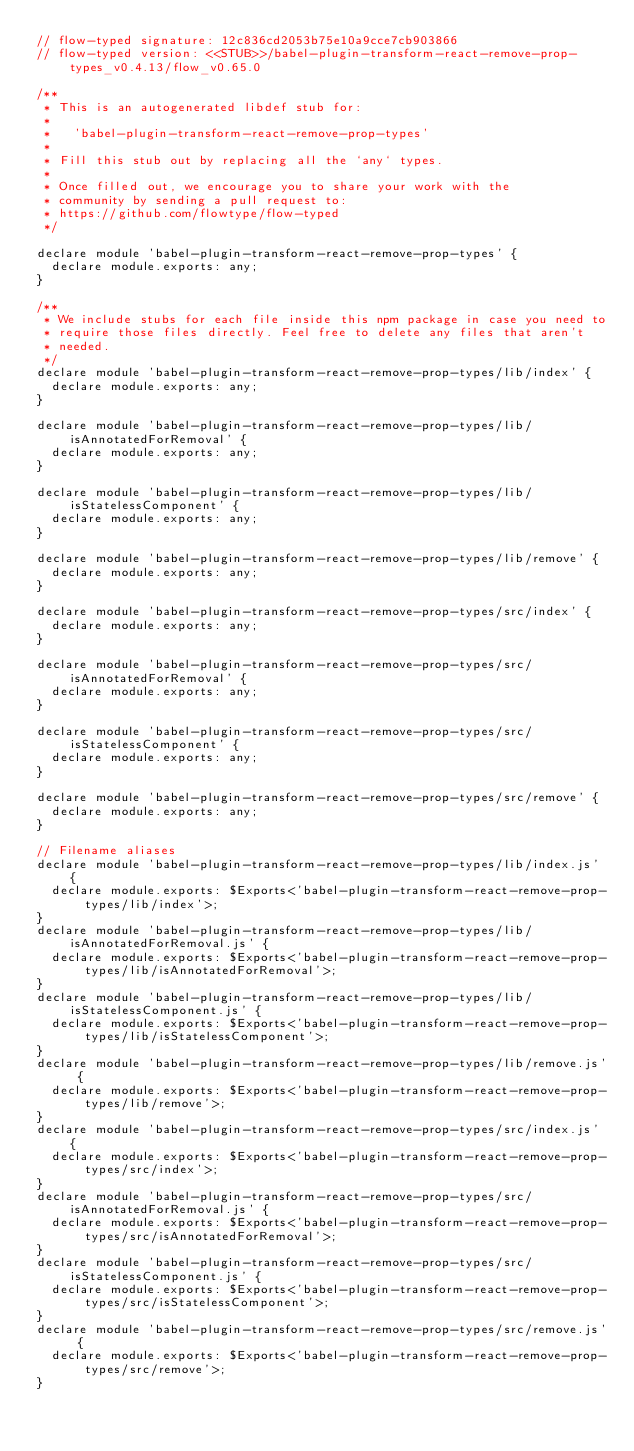<code> <loc_0><loc_0><loc_500><loc_500><_JavaScript_>// flow-typed signature: 12c836cd2053b75e10a9cce7cb903866
// flow-typed version: <<STUB>>/babel-plugin-transform-react-remove-prop-types_v0.4.13/flow_v0.65.0

/**
 * This is an autogenerated libdef stub for:
 *
 *   'babel-plugin-transform-react-remove-prop-types'
 *
 * Fill this stub out by replacing all the `any` types.
 *
 * Once filled out, we encourage you to share your work with the
 * community by sending a pull request to:
 * https://github.com/flowtype/flow-typed
 */

declare module 'babel-plugin-transform-react-remove-prop-types' {
  declare module.exports: any;
}

/**
 * We include stubs for each file inside this npm package in case you need to
 * require those files directly. Feel free to delete any files that aren't
 * needed.
 */
declare module 'babel-plugin-transform-react-remove-prop-types/lib/index' {
  declare module.exports: any;
}

declare module 'babel-plugin-transform-react-remove-prop-types/lib/isAnnotatedForRemoval' {
  declare module.exports: any;
}

declare module 'babel-plugin-transform-react-remove-prop-types/lib/isStatelessComponent' {
  declare module.exports: any;
}

declare module 'babel-plugin-transform-react-remove-prop-types/lib/remove' {
  declare module.exports: any;
}

declare module 'babel-plugin-transform-react-remove-prop-types/src/index' {
  declare module.exports: any;
}

declare module 'babel-plugin-transform-react-remove-prop-types/src/isAnnotatedForRemoval' {
  declare module.exports: any;
}

declare module 'babel-plugin-transform-react-remove-prop-types/src/isStatelessComponent' {
  declare module.exports: any;
}

declare module 'babel-plugin-transform-react-remove-prop-types/src/remove' {
  declare module.exports: any;
}

// Filename aliases
declare module 'babel-plugin-transform-react-remove-prop-types/lib/index.js' {
  declare module.exports: $Exports<'babel-plugin-transform-react-remove-prop-types/lib/index'>;
}
declare module 'babel-plugin-transform-react-remove-prop-types/lib/isAnnotatedForRemoval.js' {
  declare module.exports: $Exports<'babel-plugin-transform-react-remove-prop-types/lib/isAnnotatedForRemoval'>;
}
declare module 'babel-plugin-transform-react-remove-prop-types/lib/isStatelessComponent.js' {
  declare module.exports: $Exports<'babel-plugin-transform-react-remove-prop-types/lib/isStatelessComponent'>;
}
declare module 'babel-plugin-transform-react-remove-prop-types/lib/remove.js' {
  declare module.exports: $Exports<'babel-plugin-transform-react-remove-prop-types/lib/remove'>;
}
declare module 'babel-plugin-transform-react-remove-prop-types/src/index.js' {
  declare module.exports: $Exports<'babel-plugin-transform-react-remove-prop-types/src/index'>;
}
declare module 'babel-plugin-transform-react-remove-prop-types/src/isAnnotatedForRemoval.js' {
  declare module.exports: $Exports<'babel-plugin-transform-react-remove-prop-types/src/isAnnotatedForRemoval'>;
}
declare module 'babel-plugin-transform-react-remove-prop-types/src/isStatelessComponent.js' {
  declare module.exports: $Exports<'babel-plugin-transform-react-remove-prop-types/src/isStatelessComponent'>;
}
declare module 'babel-plugin-transform-react-remove-prop-types/src/remove.js' {
  declare module.exports: $Exports<'babel-plugin-transform-react-remove-prop-types/src/remove'>;
}
</code> 